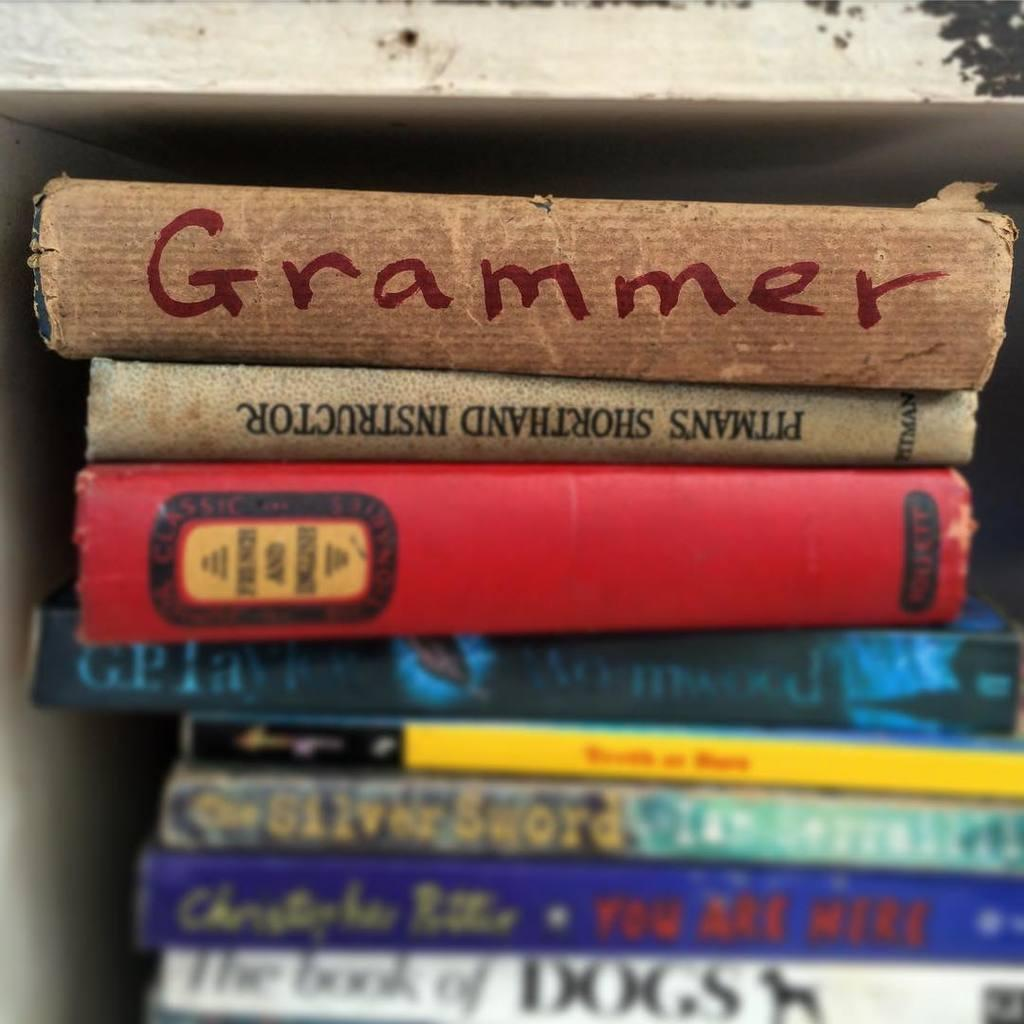Provide a one-sentence caption for the provided image. A book titled Grammer is on top of a stack of books. 